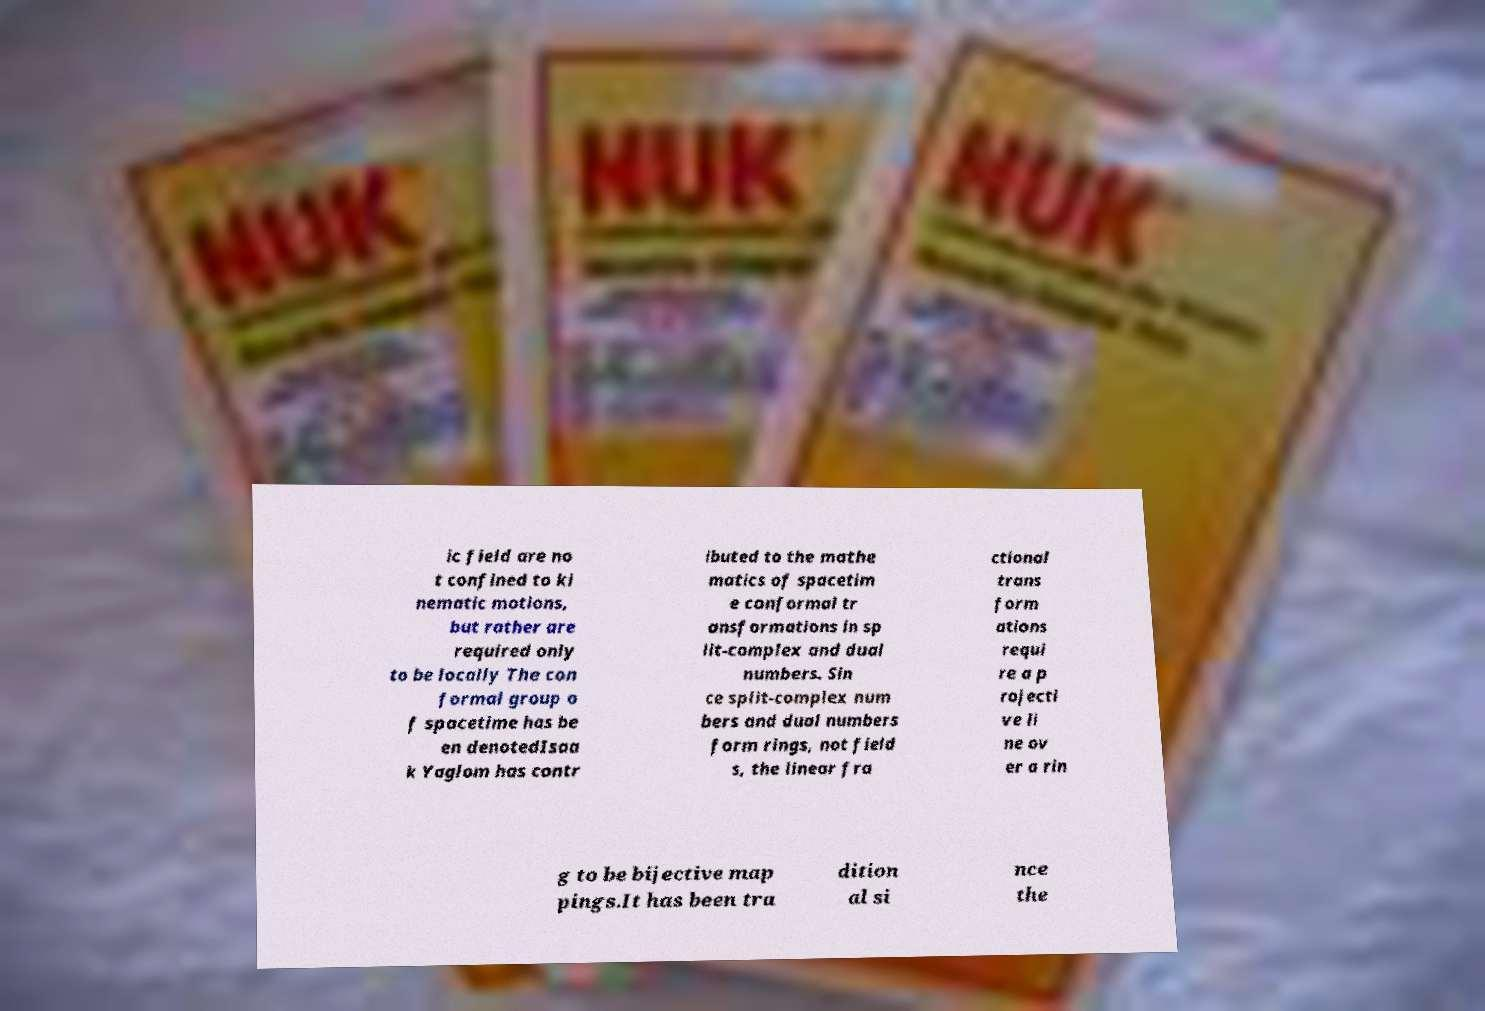Could you assist in decoding the text presented in this image and type it out clearly? ic field are no t confined to ki nematic motions, but rather are required only to be locally The con formal group o f spacetime has be en denotedIsaa k Yaglom has contr ibuted to the mathe matics of spacetim e conformal tr ansformations in sp lit-complex and dual numbers. Sin ce split-complex num bers and dual numbers form rings, not field s, the linear fra ctional trans form ations requi re a p rojecti ve li ne ov er a rin g to be bijective map pings.It has been tra dition al si nce the 